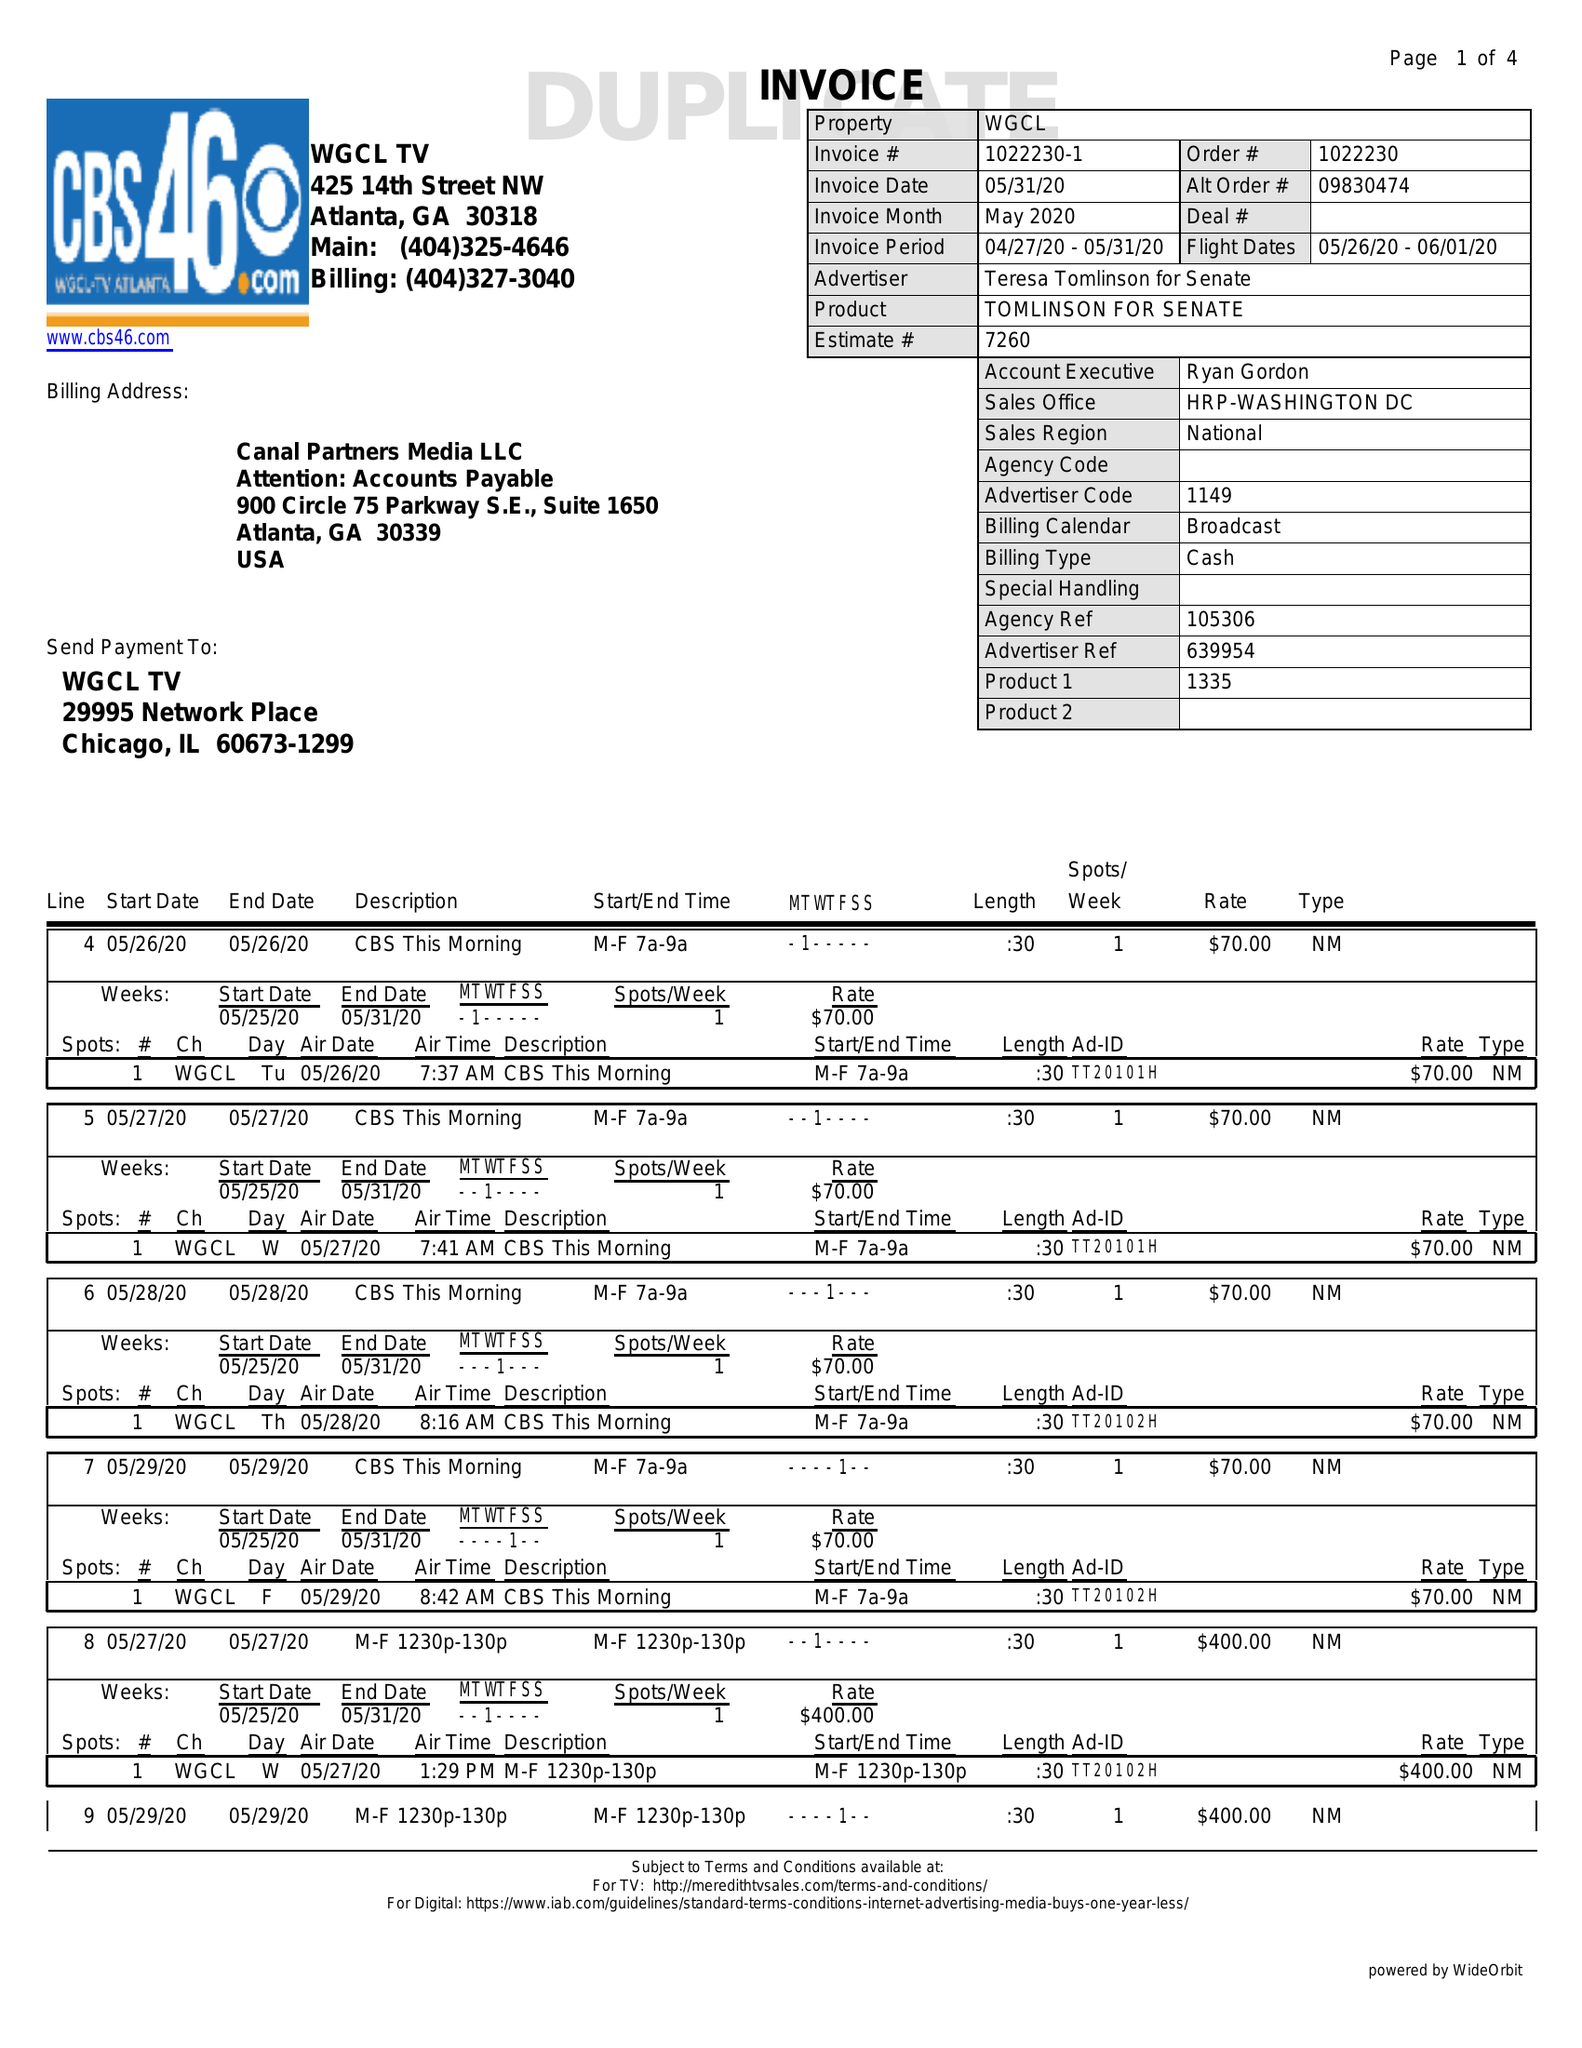What is the value for the flight_to?
Answer the question using a single word or phrase. 06/01/20 